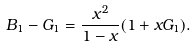<formula> <loc_0><loc_0><loc_500><loc_500>B _ { 1 } - G _ { 1 } = \frac { x ^ { 2 } } { 1 - x } ( 1 + x G _ { 1 } ) .</formula> 